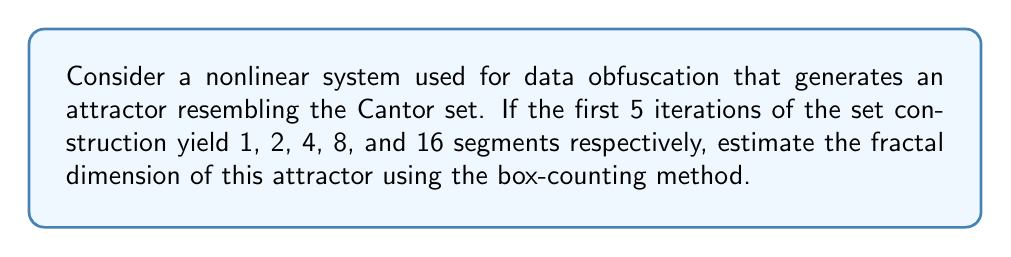Can you solve this math problem? To estimate the fractal dimension using the box-counting method, we follow these steps:

1) First, we need to understand the relationship between the number of segments (N) and the scale factor (r) for each iteration:

   Iteration 0: N = 1, r = 1
   Iteration 1: N = 2, r = 1/3
   Iteration 2: N = 4, r = 1/9
   Iteration 3: N = 8, r = 1/27
   Iteration 4: N = 16, r = 1/81

2) The fractal dimension D is given by the formula:

   $$D = \lim_{r \to 0} \frac{\log N(r)}{\log(1/r)}$$

3) We can estimate this by calculating D for each iteration and taking the average:

   For iteration 1: 
   $$D_1 = \frac{\log 2}{\log 3} \approx 0.6309$$

   For iteration 2:
   $$D_2 = \frac{\log 4}{\log 9} \approx 0.6309$$

   For iteration 3:
   $$D_3 = \frac{\log 8}{\log 27} \approx 0.6309$$

   For iteration 4:
   $$D_4 = \frac{\log 16}{\log 81} \approx 0.6309$$

4) We can see that the estimated dimension is consistent across iterations.

5) This value is close to the theoretical fractal dimension of the Cantor set, which is:

   $$D = \frac{\log 2}{\log 3} \approx 0.6309$$

Therefore, our estimate of the fractal dimension of the attractor is approximately 0.6309.
Answer: $\frac{\log 2}{\log 3} \approx 0.6309$ 